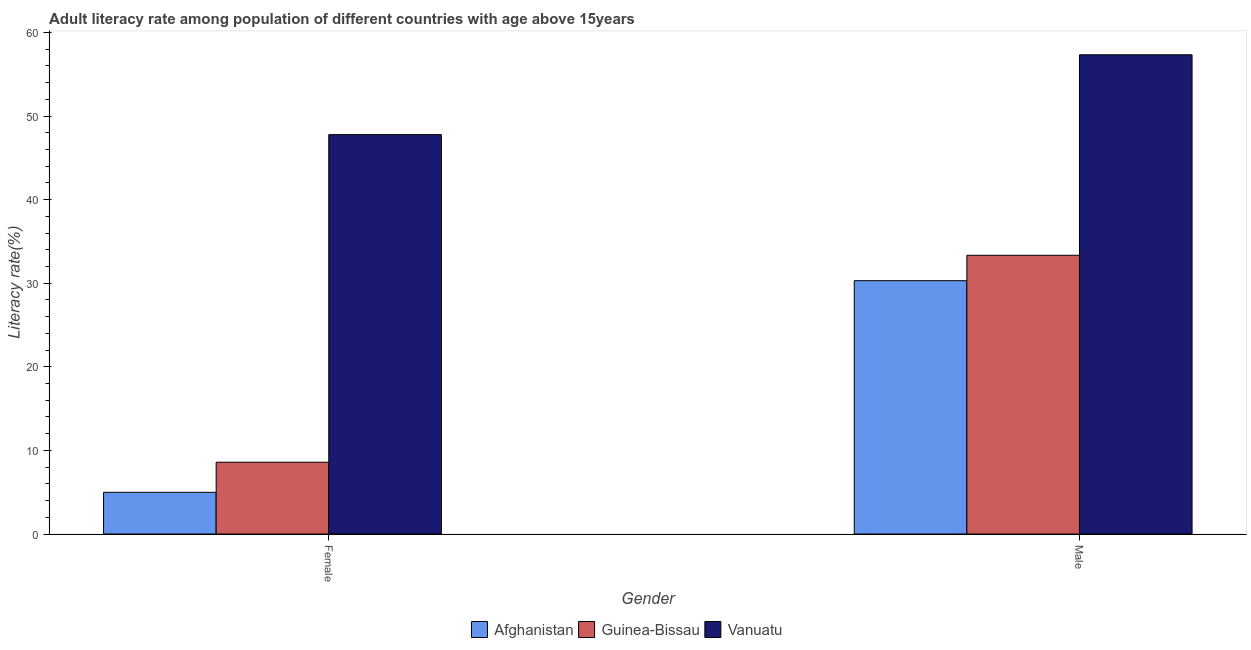How many different coloured bars are there?
Give a very brief answer. 3. How many groups of bars are there?
Make the answer very short. 2. Are the number of bars per tick equal to the number of legend labels?
Your answer should be very brief. Yes. How many bars are there on the 1st tick from the right?
Ensure brevity in your answer.  3. What is the label of the 2nd group of bars from the left?
Your answer should be compact. Male. What is the male adult literacy rate in Vanuatu?
Provide a short and direct response. 57.34. Across all countries, what is the maximum male adult literacy rate?
Provide a succinct answer. 57.34. Across all countries, what is the minimum female adult literacy rate?
Provide a short and direct response. 4.99. In which country was the female adult literacy rate maximum?
Your response must be concise. Vanuatu. In which country was the male adult literacy rate minimum?
Ensure brevity in your answer.  Afghanistan. What is the total male adult literacy rate in the graph?
Provide a short and direct response. 120.99. What is the difference between the female adult literacy rate in Afghanistan and that in Guinea-Bissau?
Provide a short and direct response. -3.6. What is the difference between the male adult literacy rate in Guinea-Bissau and the female adult literacy rate in Vanuatu?
Give a very brief answer. -14.43. What is the average female adult literacy rate per country?
Make the answer very short. 20.45. What is the difference between the female adult literacy rate and male adult literacy rate in Guinea-Bissau?
Give a very brief answer. -24.76. In how many countries, is the female adult literacy rate greater than 58 %?
Give a very brief answer. 0. What is the ratio of the male adult literacy rate in Vanuatu to that in Afghanistan?
Give a very brief answer. 1.89. What does the 1st bar from the left in Female represents?
Ensure brevity in your answer.  Afghanistan. What does the 1st bar from the right in Female represents?
Offer a terse response. Vanuatu. How many bars are there?
Offer a very short reply. 6. How many countries are there in the graph?
Your response must be concise. 3. What is the difference between two consecutive major ticks on the Y-axis?
Ensure brevity in your answer.  10. Where does the legend appear in the graph?
Give a very brief answer. Bottom center. How many legend labels are there?
Your response must be concise. 3. How are the legend labels stacked?
Ensure brevity in your answer.  Horizontal. What is the title of the graph?
Give a very brief answer. Adult literacy rate among population of different countries with age above 15years. What is the label or title of the Y-axis?
Provide a succinct answer. Literacy rate(%). What is the Literacy rate(%) in Afghanistan in Female?
Make the answer very short. 4.99. What is the Literacy rate(%) of Guinea-Bissau in Female?
Your answer should be compact. 8.59. What is the Literacy rate(%) of Vanuatu in Female?
Your answer should be very brief. 47.78. What is the Literacy rate(%) in Afghanistan in Male?
Offer a very short reply. 30.31. What is the Literacy rate(%) in Guinea-Bissau in Male?
Your answer should be very brief. 33.35. What is the Literacy rate(%) in Vanuatu in Male?
Provide a short and direct response. 57.34. Across all Gender, what is the maximum Literacy rate(%) of Afghanistan?
Give a very brief answer. 30.31. Across all Gender, what is the maximum Literacy rate(%) of Guinea-Bissau?
Offer a terse response. 33.35. Across all Gender, what is the maximum Literacy rate(%) in Vanuatu?
Provide a succinct answer. 57.34. Across all Gender, what is the minimum Literacy rate(%) of Afghanistan?
Keep it short and to the point. 4.99. Across all Gender, what is the minimum Literacy rate(%) in Guinea-Bissau?
Offer a very short reply. 8.59. Across all Gender, what is the minimum Literacy rate(%) in Vanuatu?
Offer a very short reply. 47.78. What is the total Literacy rate(%) in Afghanistan in the graph?
Keep it short and to the point. 35.3. What is the total Literacy rate(%) of Guinea-Bissau in the graph?
Make the answer very short. 41.94. What is the total Literacy rate(%) of Vanuatu in the graph?
Ensure brevity in your answer.  105.12. What is the difference between the Literacy rate(%) in Afghanistan in Female and that in Male?
Ensure brevity in your answer.  -25.32. What is the difference between the Literacy rate(%) in Guinea-Bissau in Female and that in Male?
Ensure brevity in your answer.  -24.76. What is the difference between the Literacy rate(%) in Vanuatu in Female and that in Male?
Provide a succinct answer. -9.55. What is the difference between the Literacy rate(%) of Afghanistan in Female and the Literacy rate(%) of Guinea-Bissau in Male?
Your response must be concise. -28.36. What is the difference between the Literacy rate(%) of Afghanistan in Female and the Literacy rate(%) of Vanuatu in Male?
Offer a very short reply. -52.35. What is the difference between the Literacy rate(%) in Guinea-Bissau in Female and the Literacy rate(%) in Vanuatu in Male?
Offer a terse response. -48.75. What is the average Literacy rate(%) in Afghanistan per Gender?
Your answer should be very brief. 17.65. What is the average Literacy rate(%) in Guinea-Bissau per Gender?
Give a very brief answer. 20.97. What is the average Literacy rate(%) of Vanuatu per Gender?
Your response must be concise. 52.56. What is the difference between the Literacy rate(%) of Afghanistan and Literacy rate(%) of Guinea-Bissau in Female?
Make the answer very short. -3.6. What is the difference between the Literacy rate(%) of Afghanistan and Literacy rate(%) of Vanuatu in Female?
Give a very brief answer. -42.8. What is the difference between the Literacy rate(%) in Guinea-Bissau and Literacy rate(%) in Vanuatu in Female?
Offer a terse response. -39.19. What is the difference between the Literacy rate(%) in Afghanistan and Literacy rate(%) in Guinea-Bissau in Male?
Your response must be concise. -3.04. What is the difference between the Literacy rate(%) in Afghanistan and Literacy rate(%) in Vanuatu in Male?
Your response must be concise. -27.03. What is the difference between the Literacy rate(%) of Guinea-Bissau and Literacy rate(%) of Vanuatu in Male?
Your response must be concise. -23.99. What is the ratio of the Literacy rate(%) in Afghanistan in Female to that in Male?
Provide a short and direct response. 0.16. What is the ratio of the Literacy rate(%) of Guinea-Bissau in Female to that in Male?
Your answer should be very brief. 0.26. What is the ratio of the Literacy rate(%) of Vanuatu in Female to that in Male?
Provide a succinct answer. 0.83. What is the difference between the highest and the second highest Literacy rate(%) in Afghanistan?
Keep it short and to the point. 25.32. What is the difference between the highest and the second highest Literacy rate(%) of Guinea-Bissau?
Offer a very short reply. 24.76. What is the difference between the highest and the second highest Literacy rate(%) of Vanuatu?
Make the answer very short. 9.55. What is the difference between the highest and the lowest Literacy rate(%) in Afghanistan?
Offer a very short reply. 25.32. What is the difference between the highest and the lowest Literacy rate(%) in Guinea-Bissau?
Give a very brief answer. 24.76. What is the difference between the highest and the lowest Literacy rate(%) of Vanuatu?
Your answer should be very brief. 9.55. 